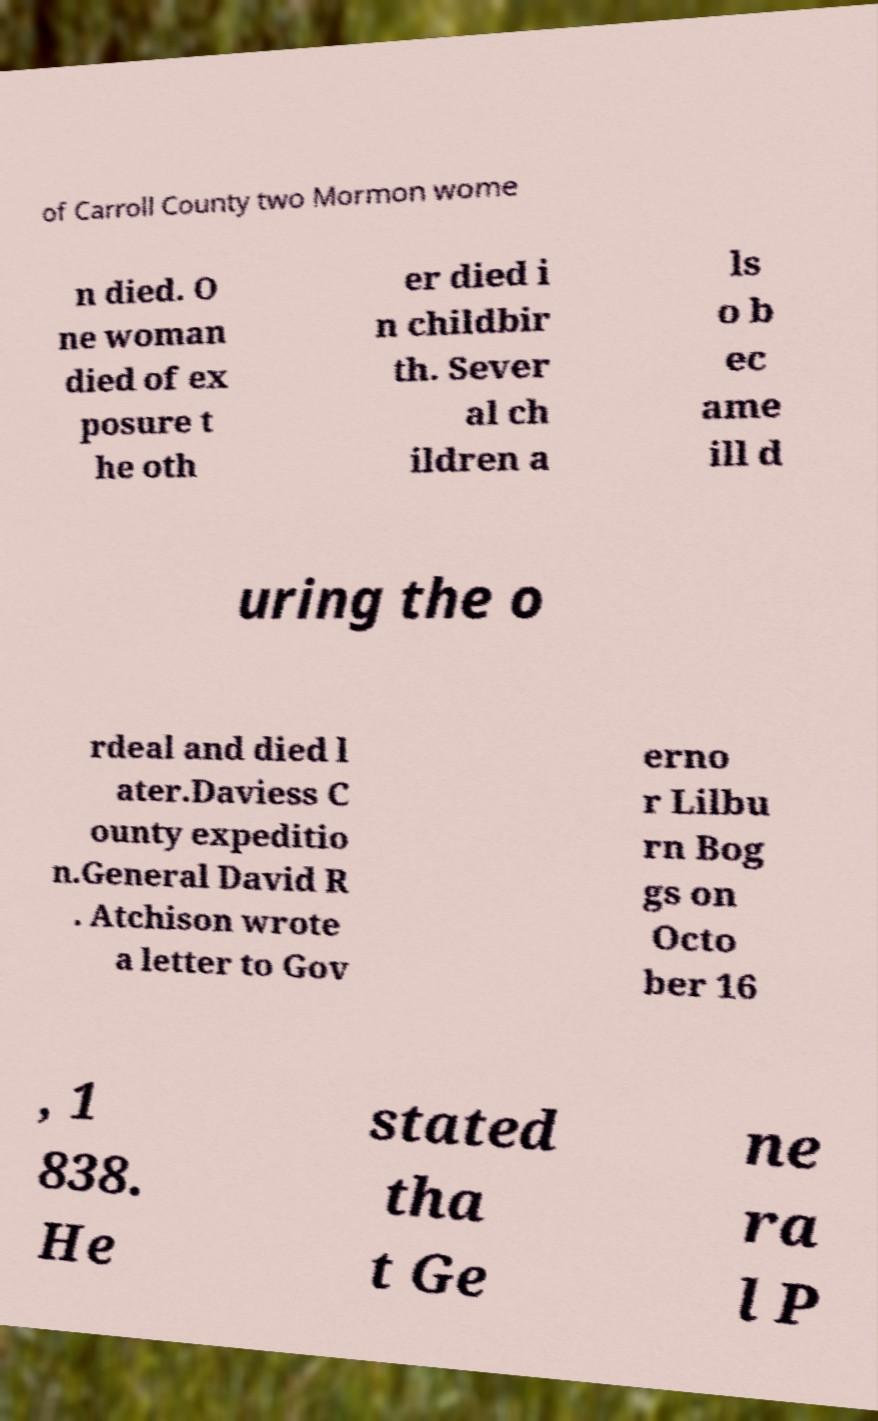Could you assist in decoding the text presented in this image and type it out clearly? of Carroll County two Mormon wome n died. O ne woman died of ex posure t he oth er died i n childbir th. Sever al ch ildren a ls o b ec ame ill d uring the o rdeal and died l ater.Daviess C ounty expeditio n.General David R . Atchison wrote a letter to Gov erno r Lilbu rn Bog gs on Octo ber 16 , 1 838. He stated tha t Ge ne ra l P 